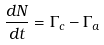<formula> <loc_0><loc_0><loc_500><loc_500>\frac { d N } { d t } = \Gamma _ { c } - \Gamma _ { a }</formula> 